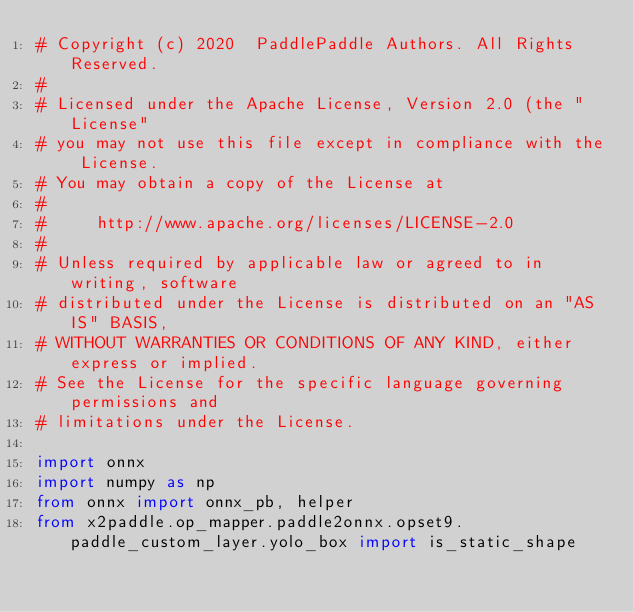Convert code to text. <code><loc_0><loc_0><loc_500><loc_500><_Python_># Copyright (c) 2020  PaddlePaddle Authors. All Rights Reserved.
#
# Licensed under the Apache License, Version 2.0 (the "License"
# you may not use this file except in compliance with the License.
# You may obtain a copy of the License at
#
#     http://www.apache.org/licenses/LICENSE-2.0
#
# Unless required by applicable law or agreed to in writing, software
# distributed under the License is distributed on an "AS IS" BASIS,
# WITHOUT WARRANTIES OR CONDITIONS OF ANY KIND, either express or implied.
# See the License for the specific language governing permissions and
# limitations under the License.

import onnx
import numpy as np
from onnx import onnx_pb, helper
from x2paddle.op_mapper.paddle2onnx.opset9.paddle_custom_layer.yolo_box import is_static_shape</code> 